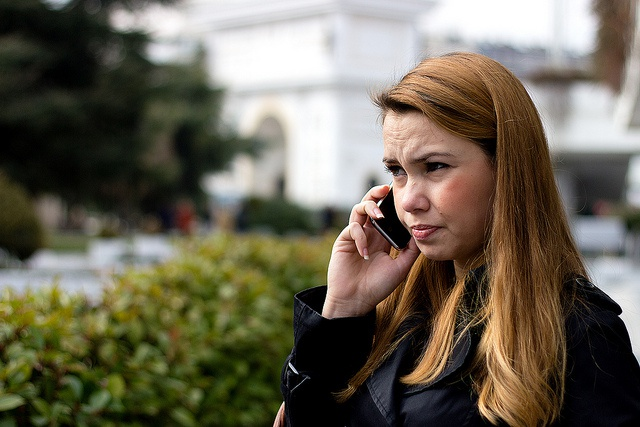Describe the objects in this image and their specific colors. I can see people in black, maroon, and gray tones and cell phone in black, darkgray, maroon, and gray tones in this image. 